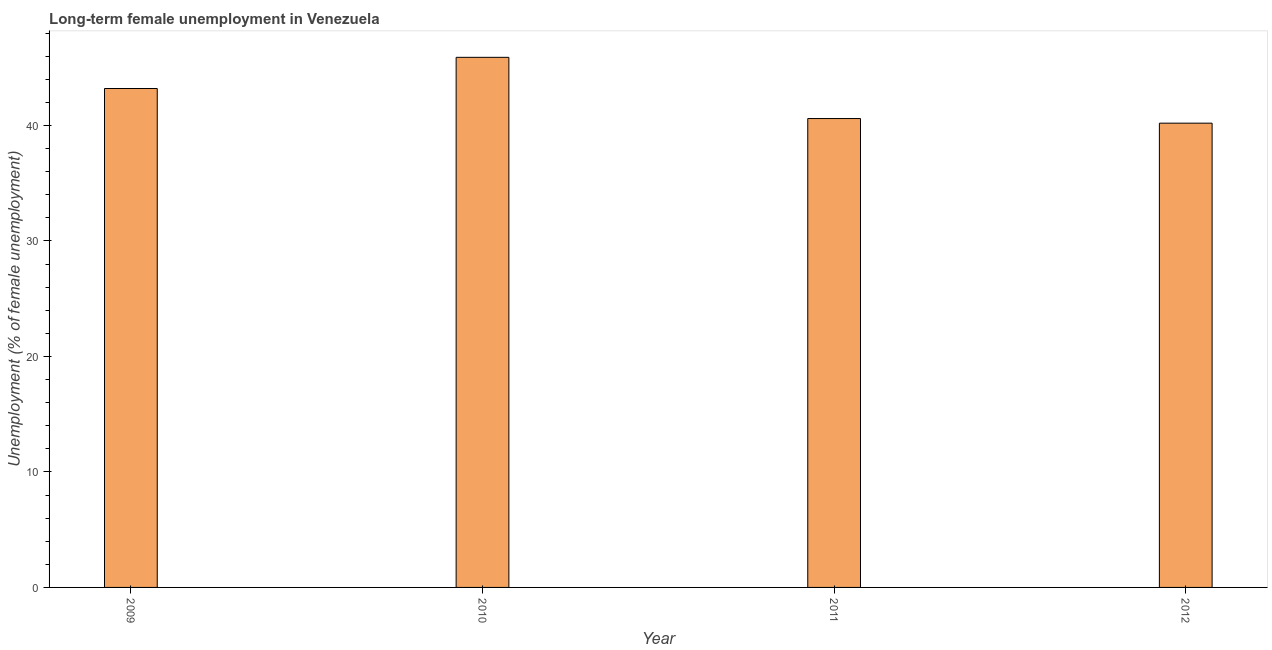Does the graph contain any zero values?
Make the answer very short. No. Does the graph contain grids?
Offer a terse response. No. What is the title of the graph?
Provide a succinct answer. Long-term female unemployment in Venezuela. What is the label or title of the Y-axis?
Your response must be concise. Unemployment (% of female unemployment). What is the long-term female unemployment in 2011?
Ensure brevity in your answer.  40.6. Across all years, what is the maximum long-term female unemployment?
Ensure brevity in your answer.  45.9. Across all years, what is the minimum long-term female unemployment?
Provide a short and direct response. 40.2. In which year was the long-term female unemployment minimum?
Your answer should be very brief. 2012. What is the sum of the long-term female unemployment?
Ensure brevity in your answer.  169.9. What is the average long-term female unemployment per year?
Provide a succinct answer. 42.48. What is the median long-term female unemployment?
Keep it short and to the point. 41.9. In how many years, is the long-term female unemployment greater than 22 %?
Keep it short and to the point. 4. Do a majority of the years between 2009 and 2011 (inclusive) have long-term female unemployment greater than 22 %?
Give a very brief answer. Yes. What is the ratio of the long-term female unemployment in 2009 to that in 2012?
Give a very brief answer. 1.07. What is the difference between the highest and the second highest long-term female unemployment?
Offer a terse response. 2.7. What is the difference between the highest and the lowest long-term female unemployment?
Your response must be concise. 5.7. Are all the bars in the graph horizontal?
Your answer should be compact. No. How many years are there in the graph?
Keep it short and to the point. 4. What is the Unemployment (% of female unemployment) of 2009?
Keep it short and to the point. 43.2. What is the Unemployment (% of female unemployment) of 2010?
Provide a short and direct response. 45.9. What is the Unemployment (% of female unemployment) of 2011?
Offer a very short reply. 40.6. What is the Unemployment (% of female unemployment) of 2012?
Provide a short and direct response. 40.2. What is the difference between the Unemployment (% of female unemployment) in 2009 and 2010?
Keep it short and to the point. -2.7. What is the difference between the Unemployment (% of female unemployment) in 2009 and 2012?
Your answer should be very brief. 3. What is the difference between the Unemployment (% of female unemployment) in 2010 and 2012?
Your answer should be compact. 5.7. What is the ratio of the Unemployment (% of female unemployment) in 2009 to that in 2010?
Make the answer very short. 0.94. What is the ratio of the Unemployment (% of female unemployment) in 2009 to that in 2011?
Offer a very short reply. 1.06. What is the ratio of the Unemployment (% of female unemployment) in 2009 to that in 2012?
Ensure brevity in your answer.  1.07. What is the ratio of the Unemployment (% of female unemployment) in 2010 to that in 2011?
Ensure brevity in your answer.  1.13. What is the ratio of the Unemployment (% of female unemployment) in 2010 to that in 2012?
Your response must be concise. 1.14. 